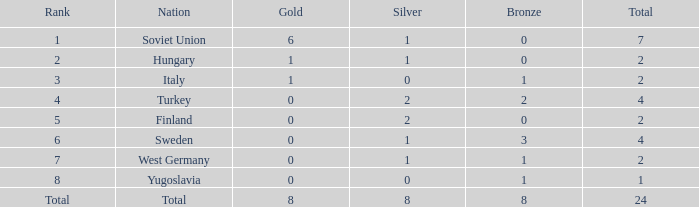What is the total sum when silver equals 0 and gold equals 1? 2.0. 